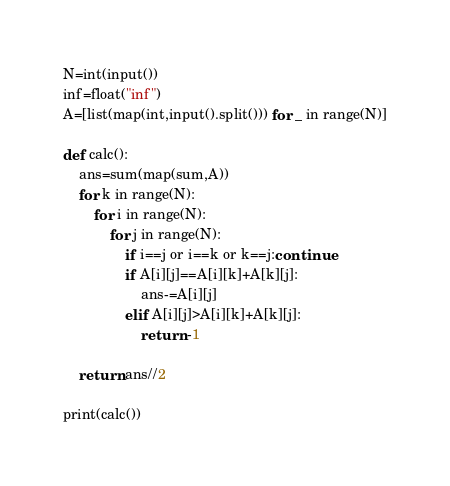<code> <loc_0><loc_0><loc_500><loc_500><_Python_>N=int(input())
inf=float("inf")
A=[list(map(int,input().split())) for _ in range(N)]

def calc():
    ans=sum(map(sum,A))
    for k in range(N):
        for i in range(N):
            for j in range(N):
                if i==j or i==k or k==j:continue
                if A[i][j]==A[i][k]+A[k][j]:
                    ans-=A[i][j]
                elif A[i][j]>A[i][k]+A[k][j]:
                    return -1

    return ans//2
                
print(calc())</code> 